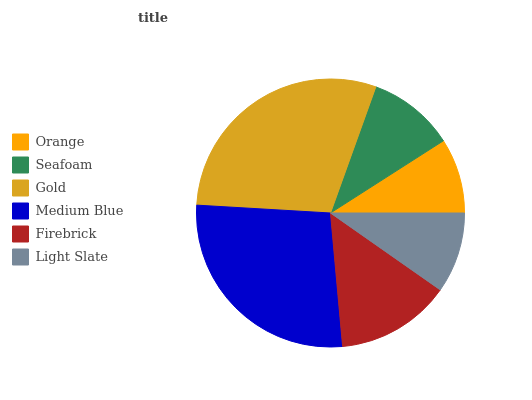Is Orange the minimum?
Answer yes or no. Yes. Is Gold the maximum?
Answer yes or no. Yes. Is Seafoam the minimum?
Answer yes or no. No. Is Seafoam the maximum?
Answer yes or no. No. Is Seafoam greater than Orange?
Answer yes or no. Yes. Is Orange less than Seafoam?
Answer yes or no. Yes. Is Orange greater than Seafoam?
Answer yes or no. No. Is Seafoam less than Orange?
Answer yes or no. No. Is Firebrick the high median?
Answer yes or no. Yes. Is Seafoam the low median?
Answer yes or no. Yes. Is Light Slate the high median?
Answer yes or no. No. Is Light Slate the low median?
Answer yes or no. No. 